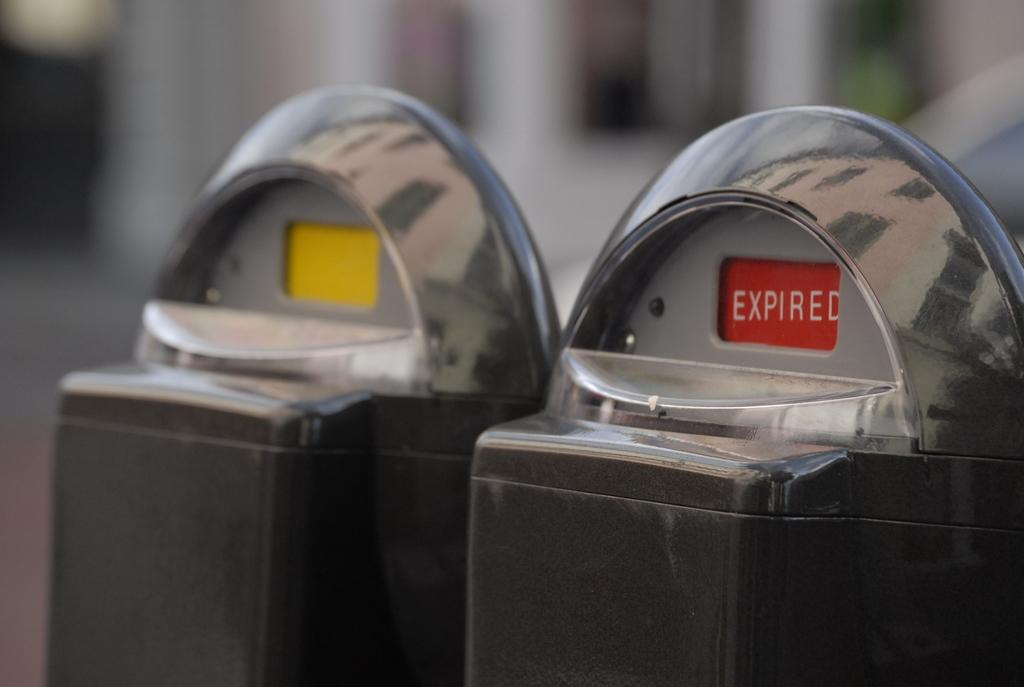<image>
Offer a succinct explanation of the picture presented. Two parking meters on a street with showing expired in red and the other showing yellow in the window. 